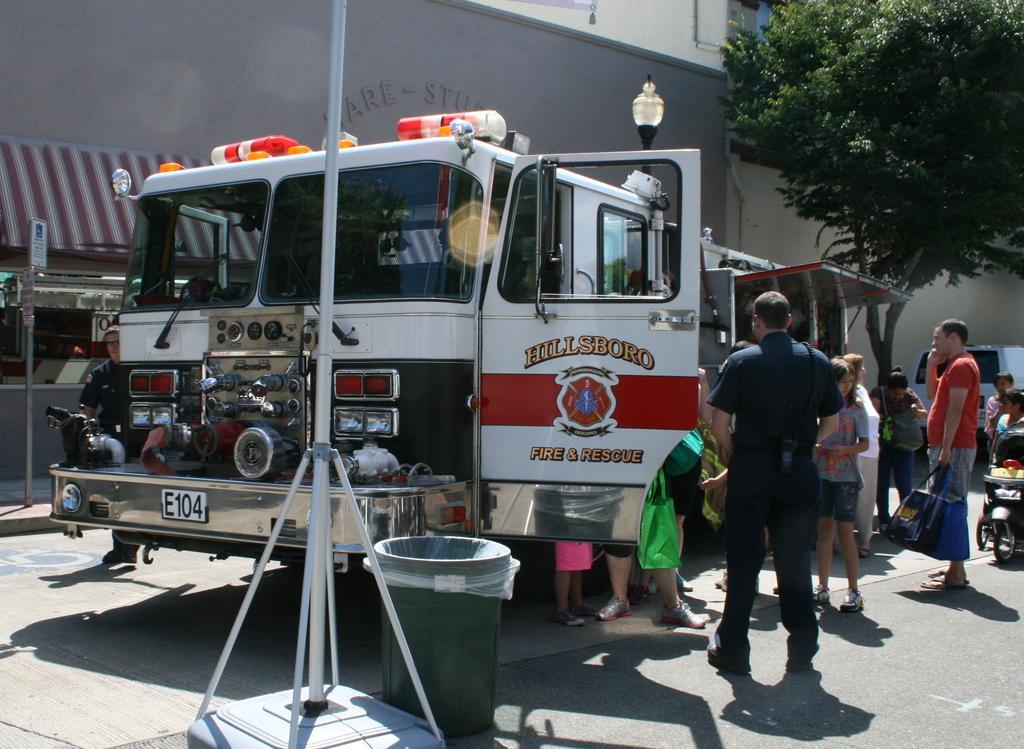Could you give a brief overview of what you see in this image? In the center of the image we can see vehicle and persons on the road. In the background we can see tree, buildings, light and vehicle. 